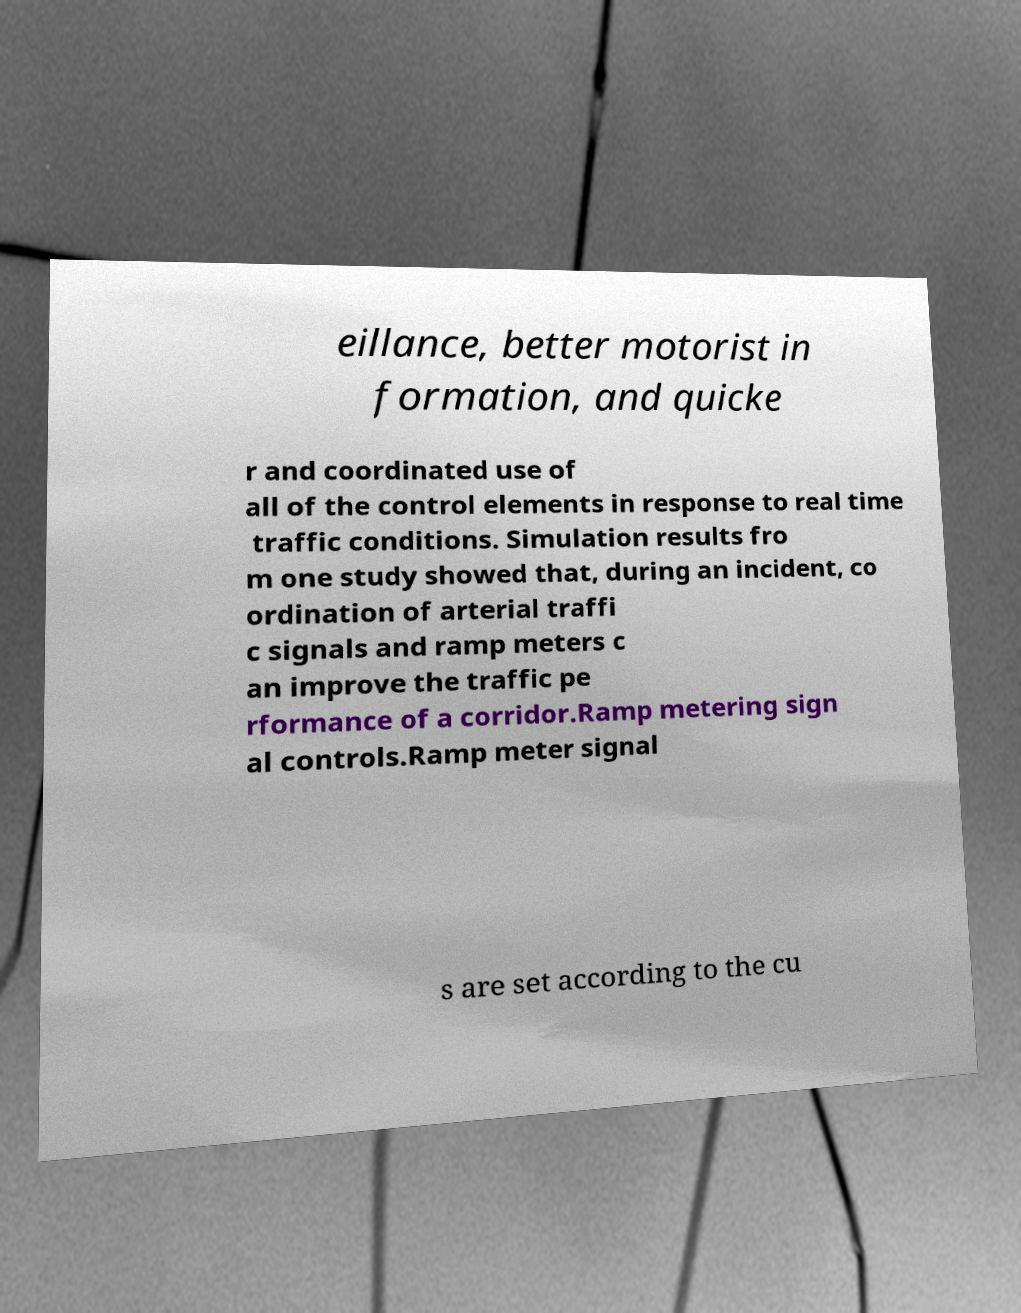Please identify and transcribe the text found in this image. eillance, better motorist in formation, and quicke r and coordinated use of all of the control elements in response to real time traffic conditions. Simulation results fro m one study showed that, during an incident, co ordination of arterial traffi c signals and ramp meters c an improve the traffic pe rformance of a corridor.Ramp metering sign al controls.Ramp meter signal s are set according to the cu 